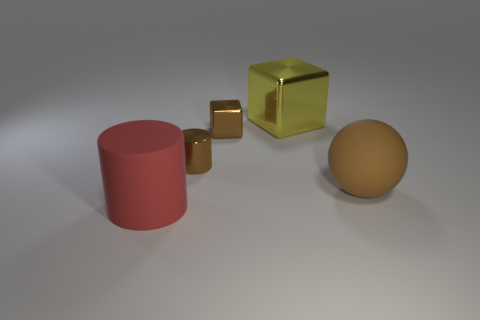Do the tiny cylinder and the object on the right side of the big metallic cube have the same color?
Provide a short and direct response. Yes. How many spheres are tiny purple things or matte objects?
Offer a terse response. 1. Is there any other thing that is the same color as the large metal object?
Give a very brief answer. No. What material is the large object behind the small thing behind the brown cylinder made of?
Give a very brief answer. Metal. Does the big cube have the same material as the thing in front of the matte ball?
Your response must be concise. No. What number of things are objects behind the large ball or large yellow shiny blocks?
Your answer should be compact. 3. Are there any cubes that have the same color as the big matte ball?
Provide a succinct answer. Yes. Is the shape of the big red rubber thing the same as the tiny metallic thing that is on the left side of the brown cube?
Keep it short and to the point. Yes. What number of large matte things are on the right side of the large block and left of the yellow metallic object?
Your response must be concise. 0. What is the material of the small brown thing that is the same shape as the large red thing?
Make the answer very short. Metal. 